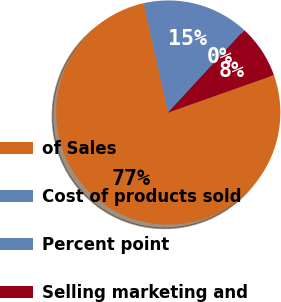Convert chart to OTSL. <chart><loc_0><loc_0><loc_500><loc_500><pie_chart><fcel>of Sales<fcel>Cost of products sold<fcel>Percent point<fcel>Selling marketing and<nl><fcel>76.88%<fcel>15.39%<fcel>0.02%<fcel>7.71%<nl></chart> 